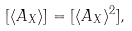<formula> <loc_0><loc_0><loc_500><loc_500>[ \langle A _ { X } \rangle ] = [ \langle A _ { X } \rangle ^ { 2 } ] ,</formula> 